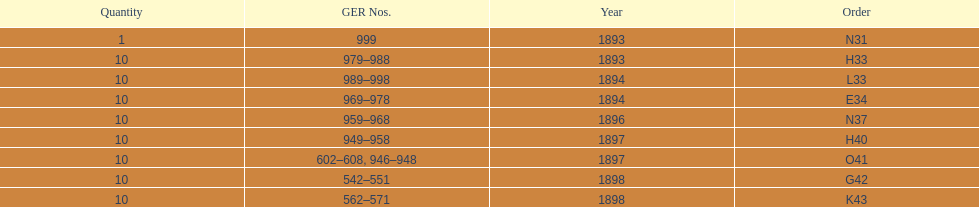In which year did the ger values hit the lowest point? 1893. 